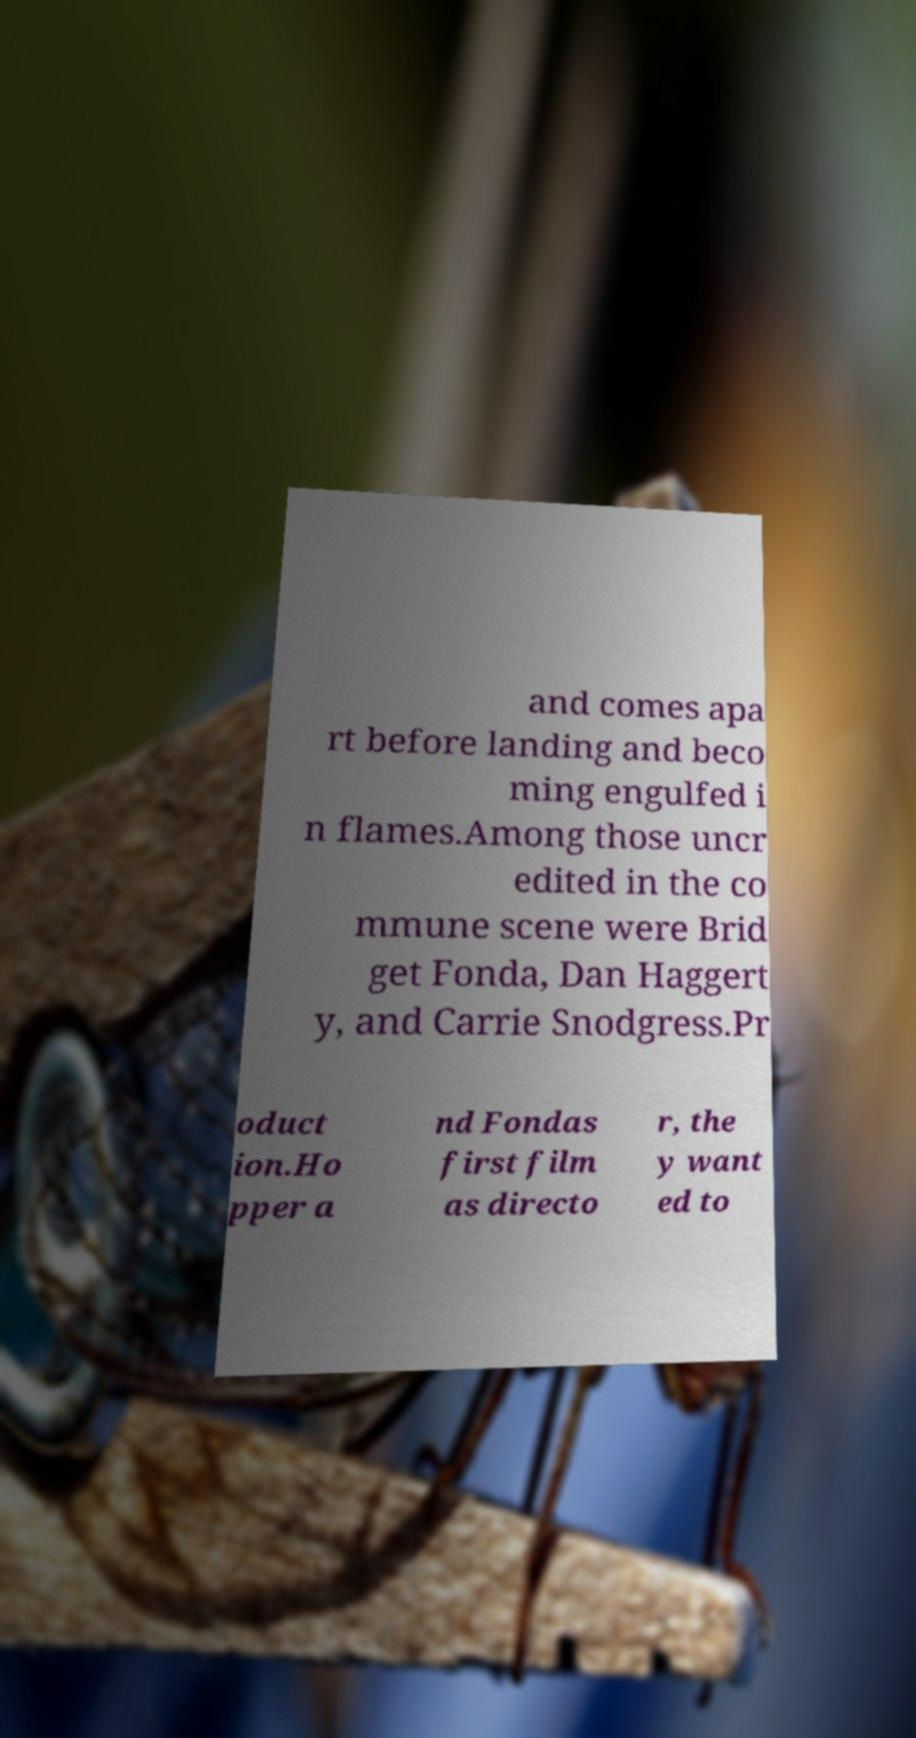Please read and relay the text visible in this image. What does it say? and comes apa rt before landing and beco ming engulfed i n flames.Among those uncr edited in the co mmune scene were Brid get Fonda, Dan Haggert y, and Carrie Snodgress.Pr oduct ion.Ho pper a nd Fondas first film as directo r, the y want ed to 